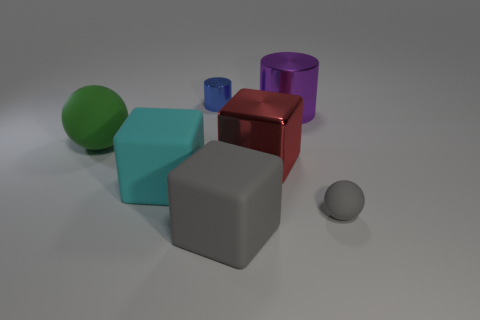How many gray rubber things have the same size as the green rubber thing?
Keep it short and to the point. 1. What number of rubber balls are both behind the red object and right of the gray matte block?
Your answer should be compact. 0. Do the sphere to the left of the cyan matte object and the gray rubber ball have the same size?
Your answer should be compact. No. Is there a matte object of the same color as the large metallic block?
Give a very brief answer. No. There is a red object that is the same material as the small cylinder; what is its size?
Your answer should be compact. Large. Are there more tiny blue metallic objects that are right of the large metal cube than large rubber things that are right of the large cyan block?
Offer a terse response. No. How many other objects are the same material as the red thing?
Keep it short and to the point. 2. Do the big block that is in front of the small gray matte object and the small gray ball have the same material?
Provide a succinct answer. Yes. What is the shape of the big red object?
Provide a succinct answer. Cube. Are there more gray spheres on the left side of the blue metallic thing than matte balls?
Keep it short and to the point. No. 